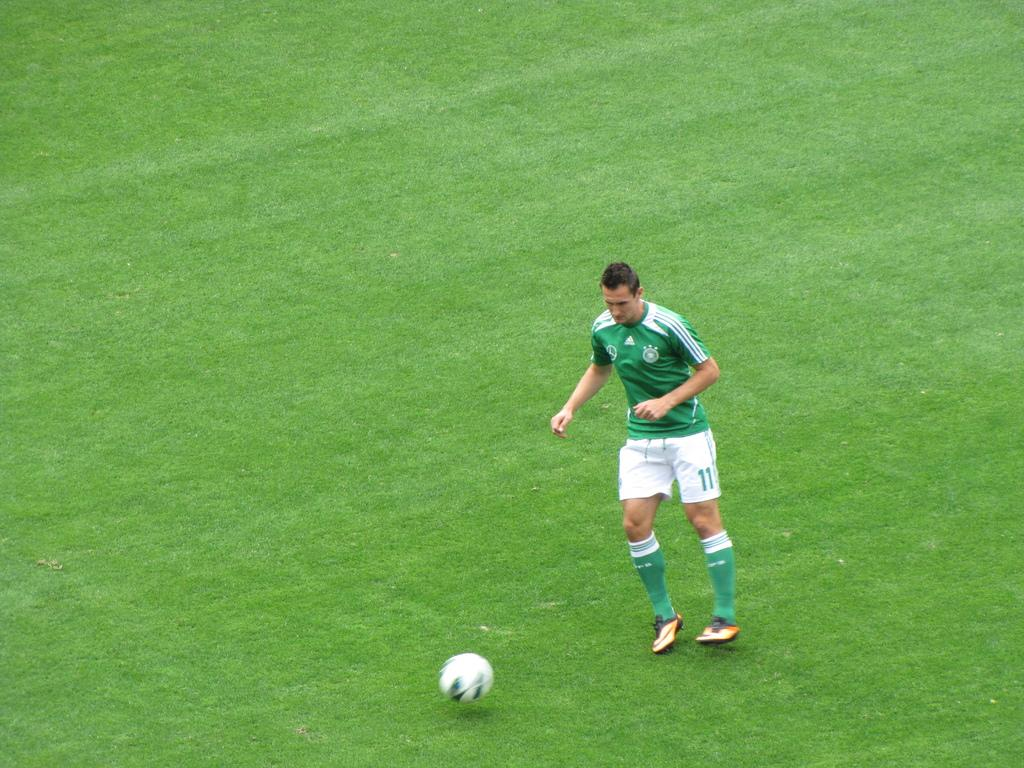<image>
Create a compact narrative representing the image presented. The mans white shorts have the number 11 on them 